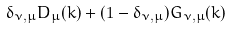<formula> <loc_0><loc_0><loc_500><loc_500>\delta _ { \nu , \mu } D _ { \mu } ( k ) + ( 1 - \delta _ { \nu , \mu } ) G _ { \nu , \mu } ( k )</formula> 